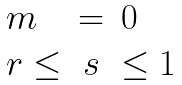Convert formula to latex. <formula><loc_0><loc_0><loc_500><loc_500>\begin{array} { l c l } { m } & { = } & { 0 } \\ { r \leq } & { s } & { \leq 1 } \end{array}</formula> 